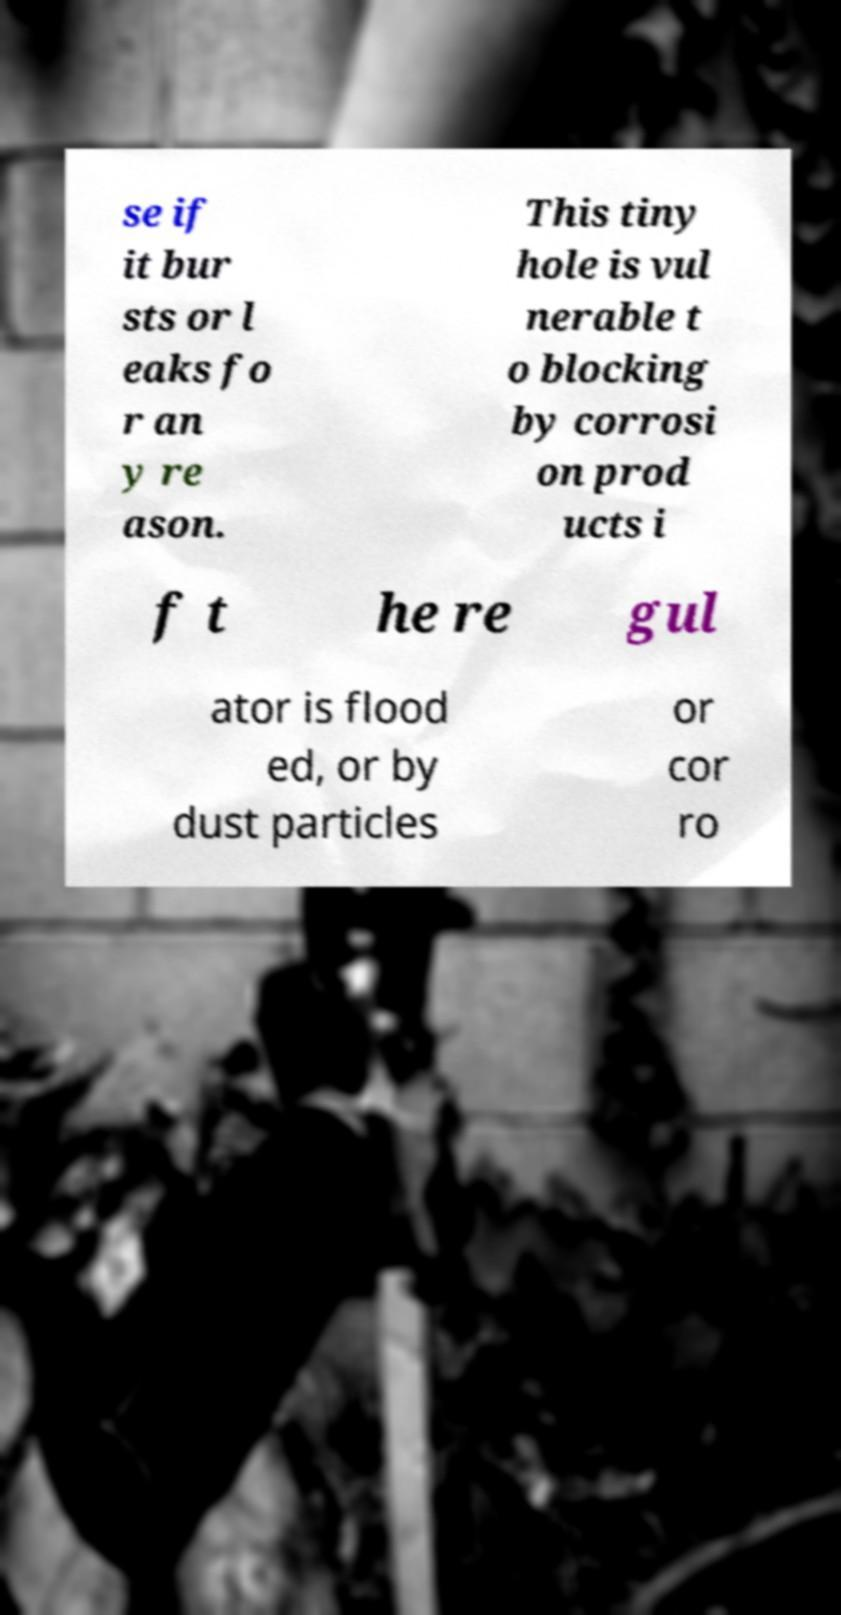Can you read and provide the text displayed in the image?This photo seems to have some interesting text. Can you extract and type it out for me? se if it bur sts or l eaks fo r an y re ason. This tiny hole is vul nerable t o blocking by corrosi on prod ucts i f t he re gul ator is flood ed, or by dust particles or cor ro 